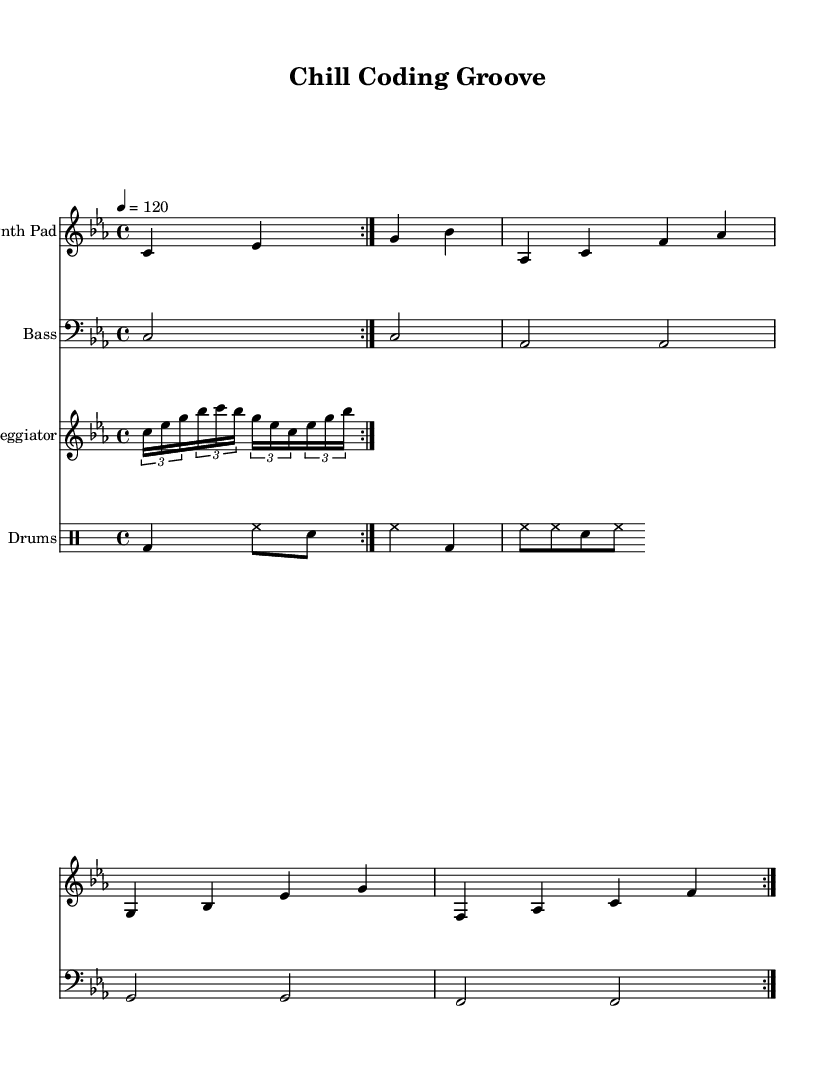What is the key signature of this music? The key signature indicated in the music is C minor, which has three flats (B flat, E flat, and A flat).
Answer: C minor What is the time signature of this music? The time signature shown in the music is 4/4, meaning there are four beats in each measure and the quarter note gets one beat.
Answer: 4/4 What is the tempo marking of this piece? The tempo marking in the sheet music indicates a tempo of 120 beats per minute, which sets a moderate pace for the piece.
Answer: 120 How many times is the synth pad section repeated? The synth pad section is marked to be repeated two times, as indicated by the "volta 2" markings above the music.
Answer: 2 What is the style of the drums used in this piece? The drums follow a typical house music style featuring a kick drum (bd), hi-hat (hh), and snare (sn), which creates a steady beat and groove typical of house tracks.
Answer: House What is the highest note in the arpeggiator section? The highest note in the arpeggiator section is C, which appears multiple times throughout the pattern.
Answer: C What rhythmic figure is used in the arpeggiator? The rhythmic figure used in the arpeggiator is a tuplet, specifically a triplet (3 notes in the place of 2), which is common in dance and house music to create a flowing feel.
Answer: Triplet 